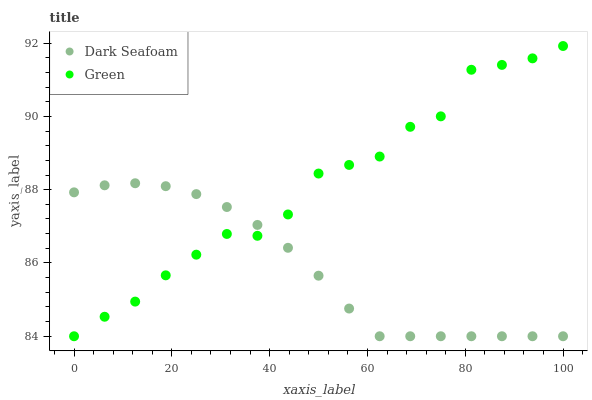Does Dark Seafoam have the minimum area under the curve?
Answer yes or no. Yes. Does Green have the maximum area under the curve?
Answer yes or no. Yes. Does Green have the minimum area under the curve?
Answer yes or no. No. Is Dark Seafoam the smoothest?
Answer yes or no. Yes. Is Green the roughest?
Answer yes or no. Yes. Is Green the smoothest?
Answer yes or no. No. Does Dark Seafoam have the lowest value?
Answer yes or no. Yes. Does Green have the highest value?
Answer yes or no. Yes. Does Green intersect Dark Seafoam?
Answer yes or no. Yes. Is Green less than Dark Seafoam?
Answer yes or no. No. Is Green greater than Dark Seafoam?
Answer yes or no. No. 